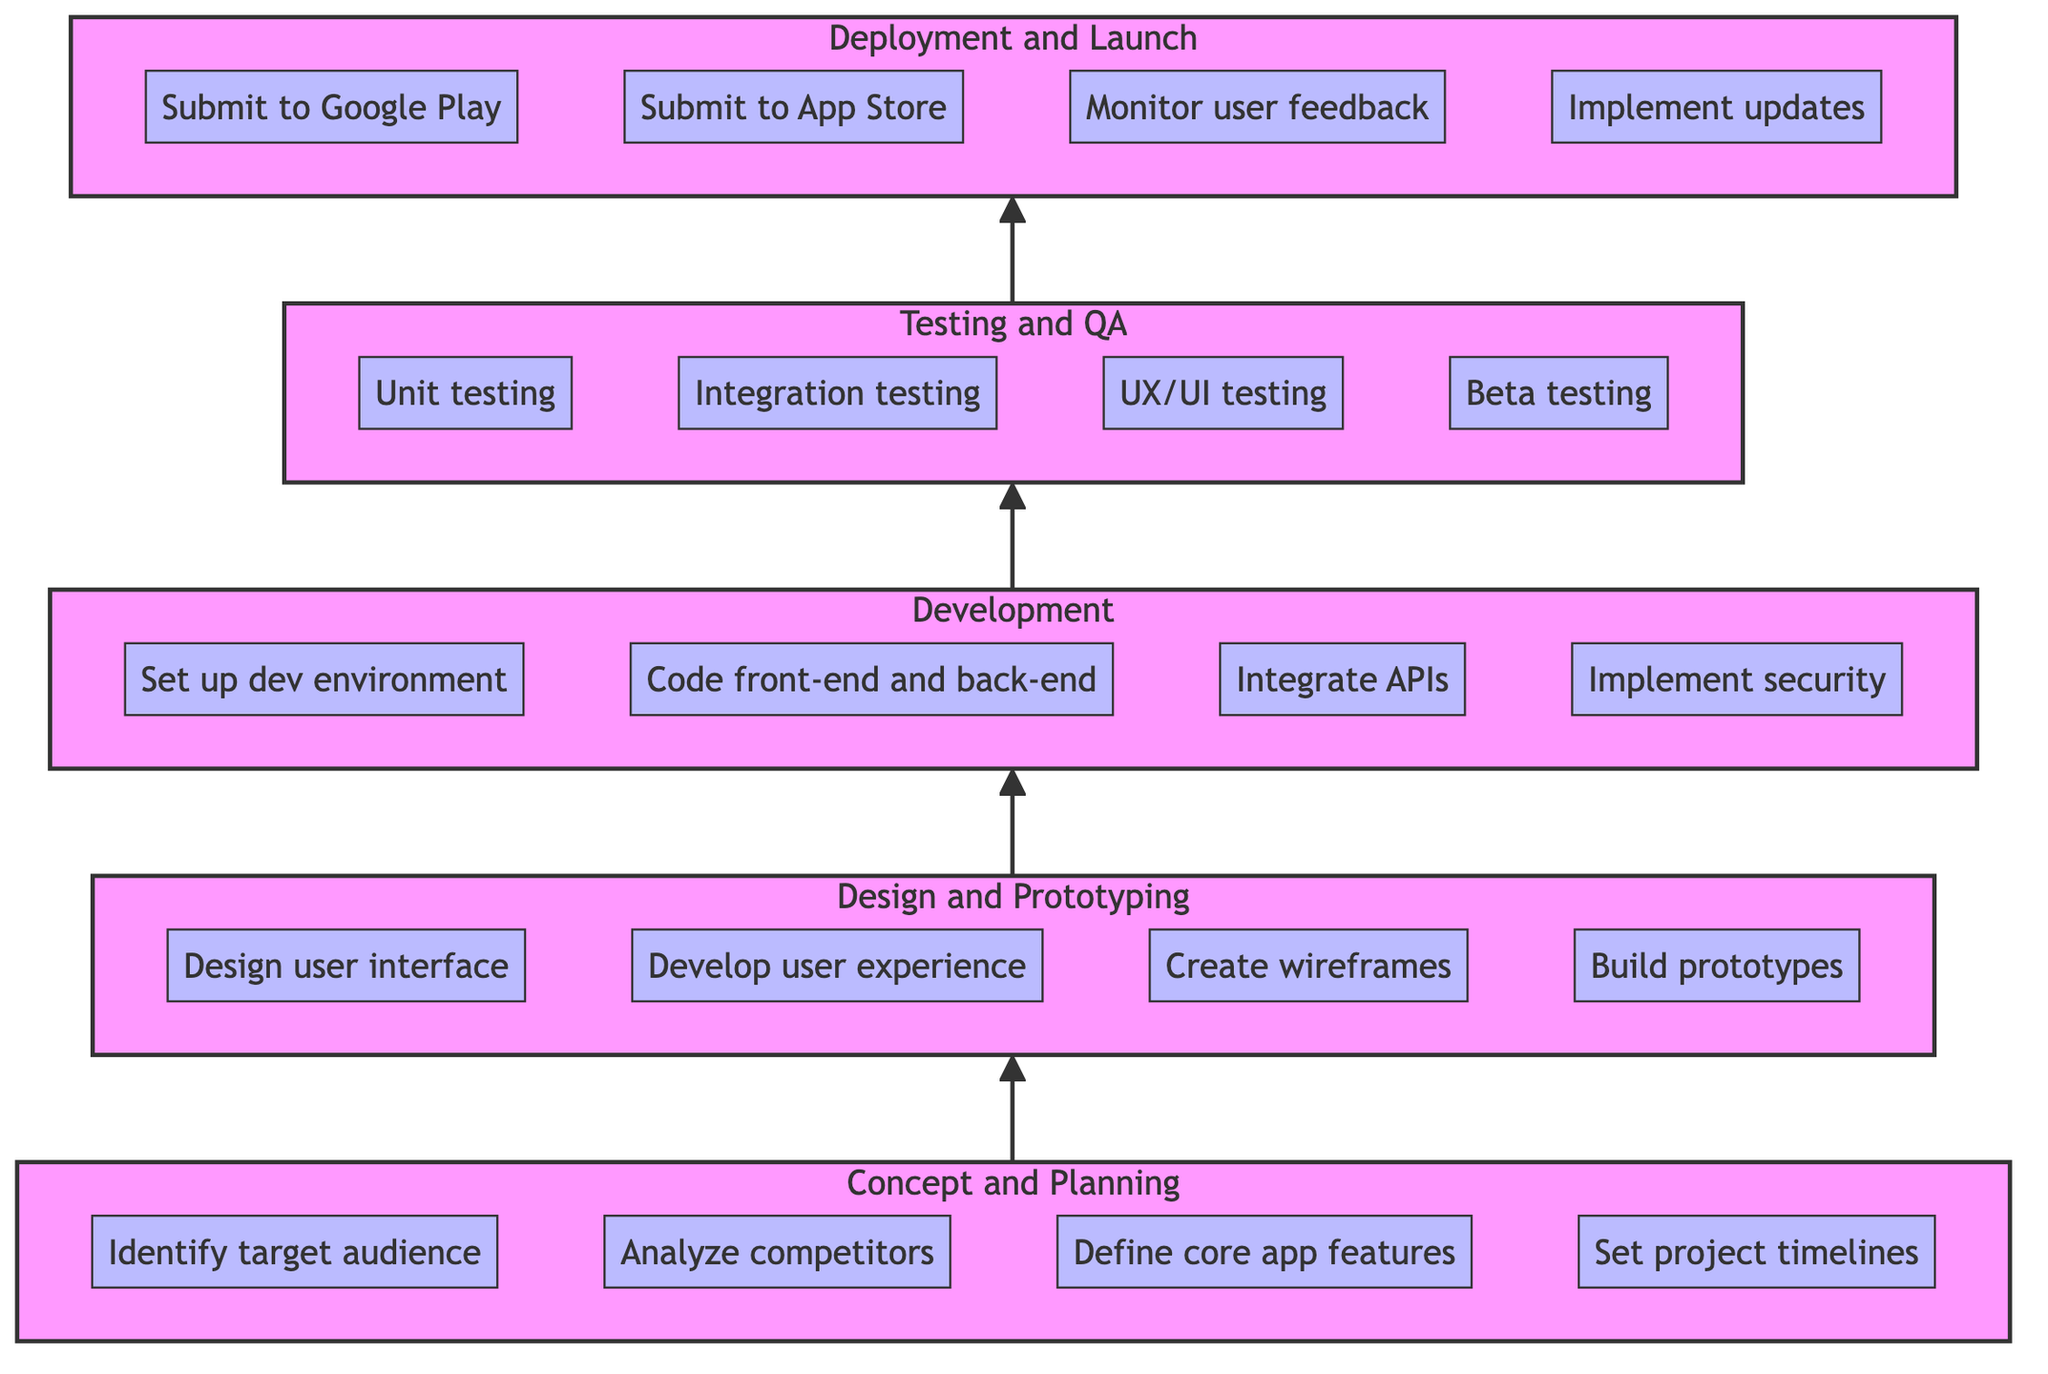What is the first phase in the diagram? The diagram begins with the bottom node labeled "Concept and Planning," which is the first step in the mobile app development process.
Answer: Concept and Planning How many key tasks are listed under the "Design and Prototyping" phase? The "Design and Prototyping" phase contains four key tasks: "Design user interface (UI)," "Develop user experience (UX)," "Create wireframes," and "Build high-fidelity prototypes." Therefore, the count of tasks is four.
Answer: 4 What is the final phase in this flow chart? The flow chart concludes with the top node labeled "Deployment and Launch," which represents the last step in the app development process.
Answer: Deployment and Launch Which phase comes before the "Testing and Quality Assurance" phase? The "Testing and Quality Assurance" phase is preceded by the "Development" phase, as indicated by the direction of the arrows in the flow chart that point upward from "Development" to "Testing and Quality Assurance."
Answer: Development What is one key task of the "Development" phase? A key task in the "Development" phase is "Code front-end and back-end," which indicates a significant part of the coding process within this phase.
Answer: Code front-end and back-end How many total phases are represented in the diagram? The diagram contains five distinct phases, which are "Concept and Planning," "Design and Prototyping," "Development," "Testing and Quality Assurance," and "Deployment and Launch." Therefore, the total count is five.
Answer: 5 What does the "Deployment and Launch" phase involve in terms of user feedback? One key task in the "Deployment and Launch" phase is "Monitor user feedback," which emphasizes the importance of assessing user responses after the app is released.
Answer: Monitor user feedback Which phase is directly connected to the "Concept and Planning" phase? The "Concept and Planning" phase is directly connected to the "Design and Prototyping" phase, as indicated by the upward arrow leading from "Concept and Planning" to "Design and Prototyping" in the flowchart.
Answer: Design and Prototyping 